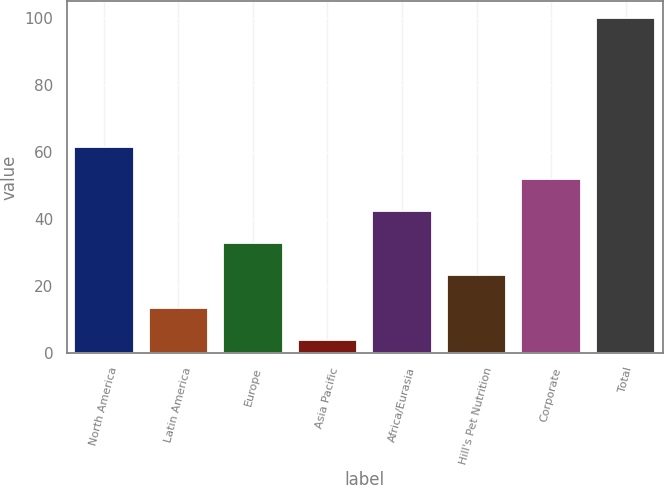<chart> <loc_0><loc_0><loc_500><loc_500><bar_chart><fcel>North America<fcel>Latin America<fcel>Europe<fcel>Asia Pacific<fcel>Africa/Eurasia<fcel>Hill's Pet Nutrition<fcel>Corporate<fcel>Total<nl><fcel>61.6<fcel>13.6<fcel>32.8<fcel>4<fcel>42.4<fcel>23.2<fcel>52<fcel>100<nl></chart> 